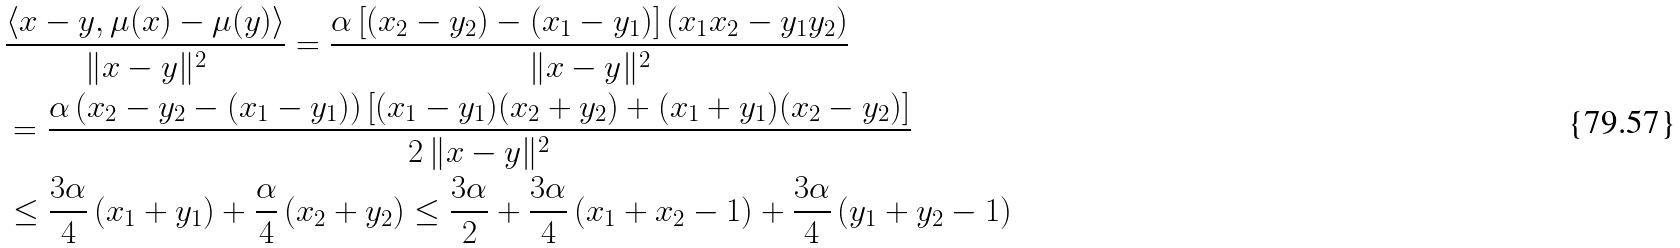Convert formula to latex. <formula><loc_0><loc_0><loc_500><loc_500>& \frac { \langle x - y , \mu ( x ) - \mu ( y ) \rangle } { \| x - y \| ^ { 2 } } = \frac { \alpha \left [ ( x _ { 2 } - y _ { 2 } ) - ( x _ { 1 } - y _ { 1 } ) \right ] \left ( x _ { 1 } x _ { 2 } - y _ { 1 } y _ { 2 } \right ) } { \| x - y \| ^ { 2 } } \\ & = \frac { \alpha \left ( x _ { 2 } - y _ { 2 } - ( x _ { 1 } - y _ { 1 } ) \right ) \left [ ( x _ { 1 } - y _ { 1 } ) ( x _ { 2 } + y _ { 2 } ) + ( x _ { 1 } + y _ { 1 } ) ( x _ { 2 } - y _ { 2 } ) \right ] } { 2 \, \| x - y \| ^ { 2 } } \\ & \leq \frac { 3 \alpha } { 4 } \left ( x _ { 1 } + y _ { 1 } \right ) + \frac { \alpha } { 4 } \left ( x _ { 2 } + y _ { 2 } \right ) \leq \frac { 3 \alpha } { 2 } + \frac { 3 \alpha } { 4 } \left ( x _ { 1 } + x _ { 2 } - 1 \right ) + \frac { 3 \alpha } { 4 } \left ( y _ { 1 } + y _ { 2 } - 1 \right )</formula> 